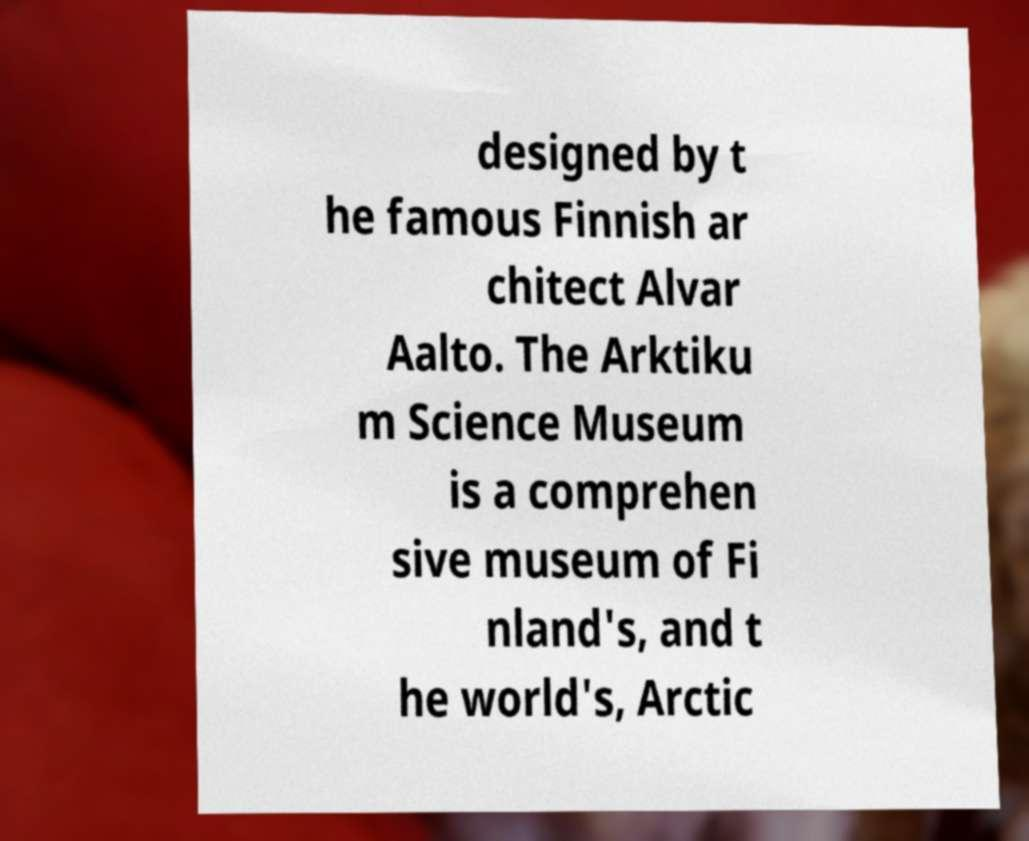Can you accurately transcribe the text from the provided image for me? designed by t he famous Finnish ar chitect Alvar Aalto. The Arktiku m Science Museum is a comprehen sive museum of Fi nland's, and t he world's, Arctic 